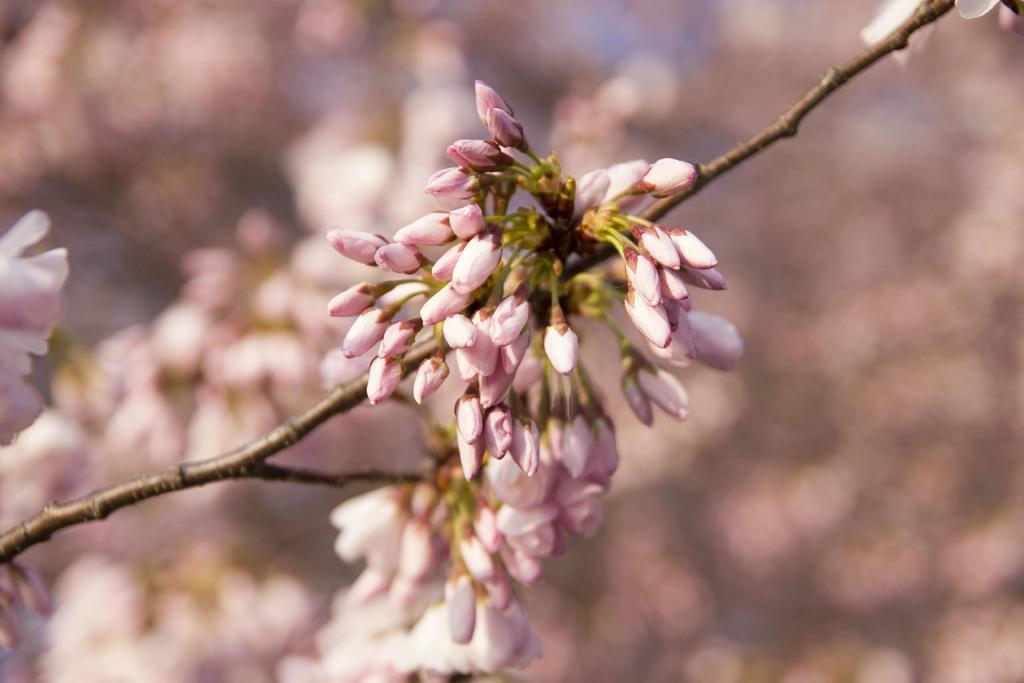How would you summarize this image in a sentence or two? In the picture I can see the branch of a flower plant and I can see the flower buds. 